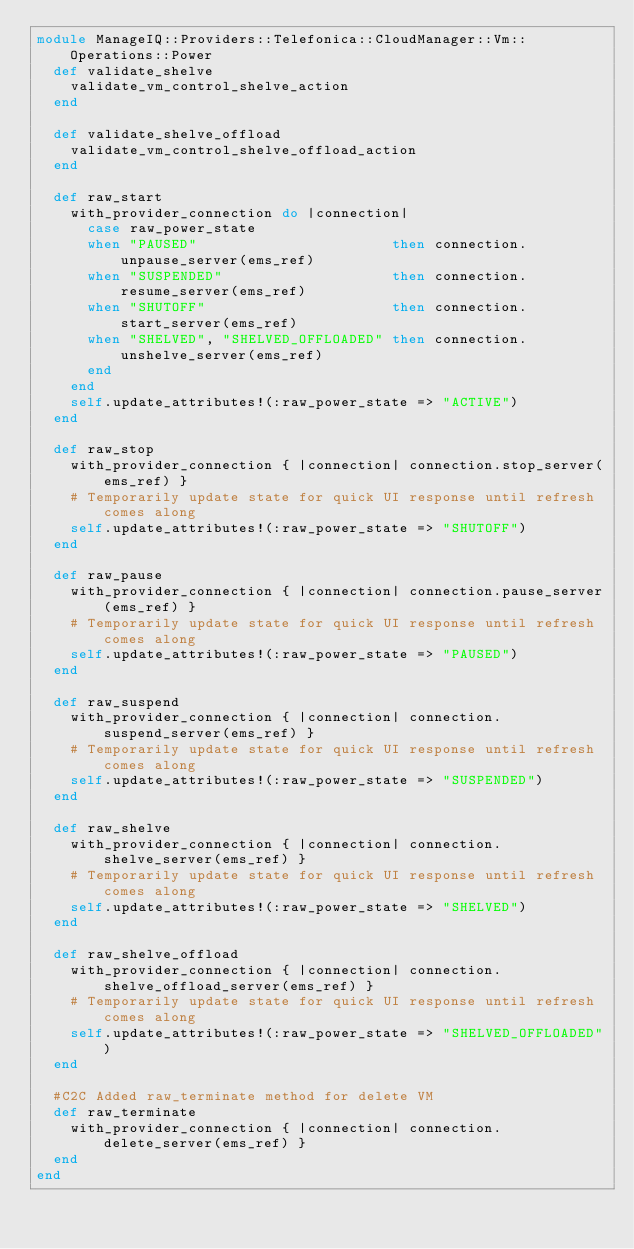Convert code to text. <code><loc_0><loc_0><loc_500><loc_500><_Ruby_>module ManageIQ::Providers::Telefonica::CloudManager::Vm::Operations::Power
  def validate_shelve
    validate_vm_control_shelve_action
  end

  def validate_shelve_offload
    validate_vm_control_shelve_offload_action
  end

  def raw_start
    with_provider_connection do |connection|
      case raw_power_state
      when "PAUSED"                       then connection.unpause_server(ems_ref)
      when "SUSPENDED"                    then connection.resume_server(ems_ref)
      when "SHUTOFF"                      then connection.start_server(ems_ref)
      when "SHELVED", "SHELVED_OFFLOADED" then connection.unshelve_server(ems_ref)
      end
    end
    self.update_attributes!(:raw_power_state => "ACTIVE")
  end

  def raw_stop
    with_provider_connection { |connection| connection.stop_server(ems_ref) }
    # Temporarily update state for quick UI response until refresh comes along
    self.update_attributes!(:raw_power_state => "SHUTOFF")
  end

  def raw_pause
    with_provider_connection { |connection| connection.pause_server(ems_ref) }
    # Temporarily update state for quick UI response until refresh comes along
    self.update_attributes!(:raw_power_state => "PAUSED")
  end

  def raw_suspend
    with_provider_connection { |connection| connection.suspend_server(ems_ref) }
    # Temporarily update state for quick UI response until refresh comes along
    self.update_attributes!(:raw_power_state => "SUSPENDED")
  end

  def raw_shelve
    with_provider_connection { |connection| connection.shelve_server(ems_ref) }
    # Temporarily update state for quick UI response until refresh comes along
    self.update_attributes!(:raw_power_state => "SHELVED")
  end

  def raw_shelve_offload
    with_provider_connection { |connection| connection.shelve_offload_server(ems_ref) }
    # Temporarily update state for quick UI response until refresh comes along
    self.update_attributes!(:raw_power_state => "SHELVED_OFFLOADED")
  end

  #C2C Added raw_terminate method for delete VM      
  def raw_terminate
    with_provider_connection { |connection| connection.delete_server(ems_ref) }
  end
end
</code> 